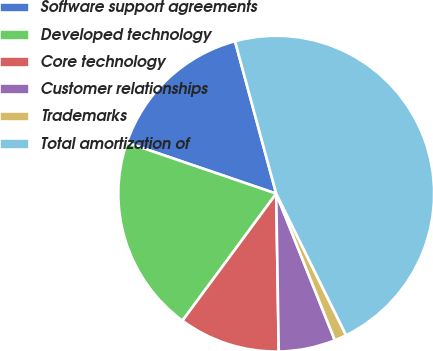Convert chart. <chart><loc_0><loc_0><loc_500><loc_500><pie_chart><fcel>Software support agreements<fcel>Developed technology<fcel>Core technology<fcel>Customer relationships<fcel>Trademarks<fcel>Total amortization of<nl><fcel>15.56%<fcel>20.12%<fcel>10.37%<fcel>5.8%<fcel>1.24%<fcel>46.9%<nl></chart> 